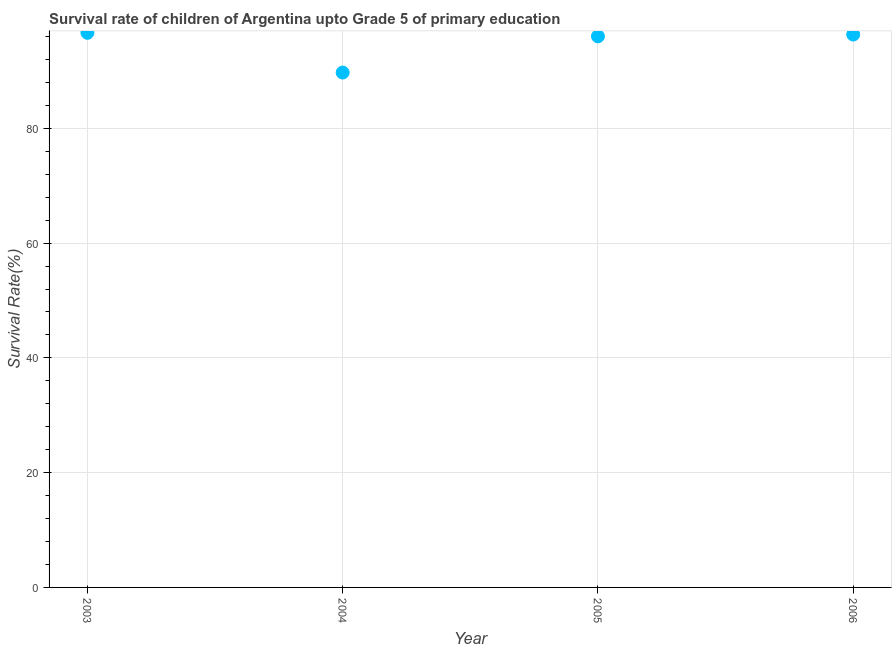What is the survival rate in 2005?
Provide a short and direct response. 96.03. Across all years, what is the maximum survival rate?
Keep it short and to the point. 96.64. Across all years, what is the minimum survival rate?
Provide a succinct answer. 89.72. What is the sum of the survival rate?
Your answer should be compact. 378.74. What is the difference between the survival rate in 2004 and 2005?
Your answer should be very brief. -6.31. What is the average survival rate per year?
Ensure brevity in your answer.  94.68. What is the median survival rate?
Make the answer very short. 96.19. What is the ratio of the survival rate in 2003 to that in 2004?
Offer a very short reply. 1.08. What is the difference between the highest and the second highest survival rate?
Ensure brevity in your answer.  0.3. Is the sum of the survival rate in 2003 and 2005 greater than the maximum survival rate across all years?
Provide a succinct answer. Yes. What is the difference between the highest and the lowest survival rate?
Your answer should be compact. 6.93. In how many years, is the survival rate greater than the average survival rate taken over all years?
Make the answer very short. 3. How many dotlines are there?
Provide a short and direct response. 1. How many years are there in the graph?
Your response must be concise. 4. What is the difference between two consecutive major ticks on the Y-axis?
Offer a terse response. 20. What is the title of the graph?
Provide a succinct answer. Survival rate of children of Argentina upto Grade 5 of primary education. What is the label or title of the X-axis?
Provide a short and direct response. Year. What is the label or title of the Y-axis?
Make the answer very short. Survival Rate(%). What is the Survival Rate(%) in 2003?
Make the answer very short. 96.64. What is the Survival Rate(%) in 2004?
Your answer should be very brief. 89.72. What is the Survival Rate(%) in 2005?
Ensure brevity in your answer.  96.03. What is the Survival Rate(%) in 2006?
Provide a short and direct response. 96.35. What is the difference between the Survival Rate(%) in 2003 and 2004?
Keep it short and to the point. 6.93. What is the difference between the Survival Rate(%) in 2003 and 2005?
Your answer should be compact. 0.62. What is the difference between the Survival Rate(%) in 2003 and 2006?
Give a very brief answer. 0.3. What is the difference between the Survival Rate(%) in 2004 and 2005?
Keep it short and to the point. -6.31. What is the difference between the Survival Rate(%) in 2004 and 2006?
Offer a very short reply. -6.63. What is the difference between the Survival Rate(%) in 2005 and 2006?
Provide a short and direct response. -0.32. What is the ratio of the Survival Rate(%) in 2003 to that in 2004?
Ensure brevity in your answer.  1.08. What is the ratio of the Survival Rate(%) in 2004 to that in 2005?
Your answer should be compact. 0.93. What is the ratio of the Survival Rate(%) in 2005 to that in 2006?
Your response must be concise. 1. 